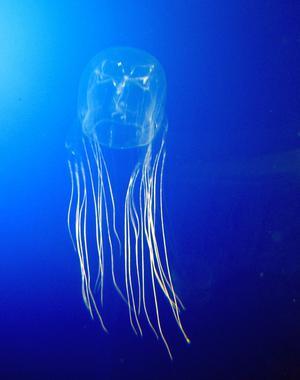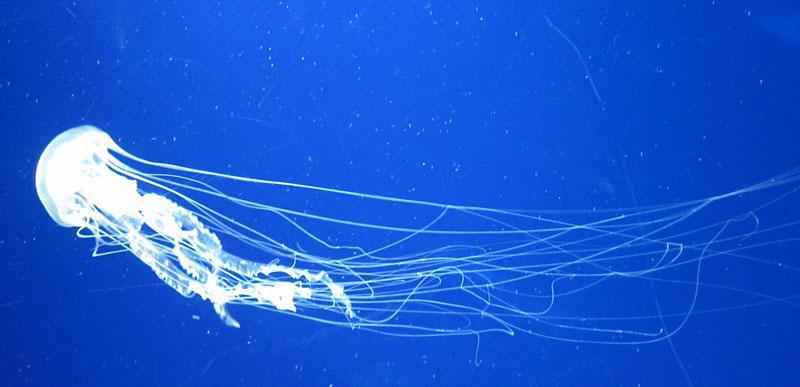The first image is the image on the left, the second image is the image on the right. Considering the images on both sides, is "the right image has a lone jellyfish swimming to the left" valid? Answer yes or no. Yes. The first image is the image on the left, the second image is the image on the right. Considering the images on both sides, is "There are a total of 2 jelly fish." valid? Answer yes or no. Yes. 